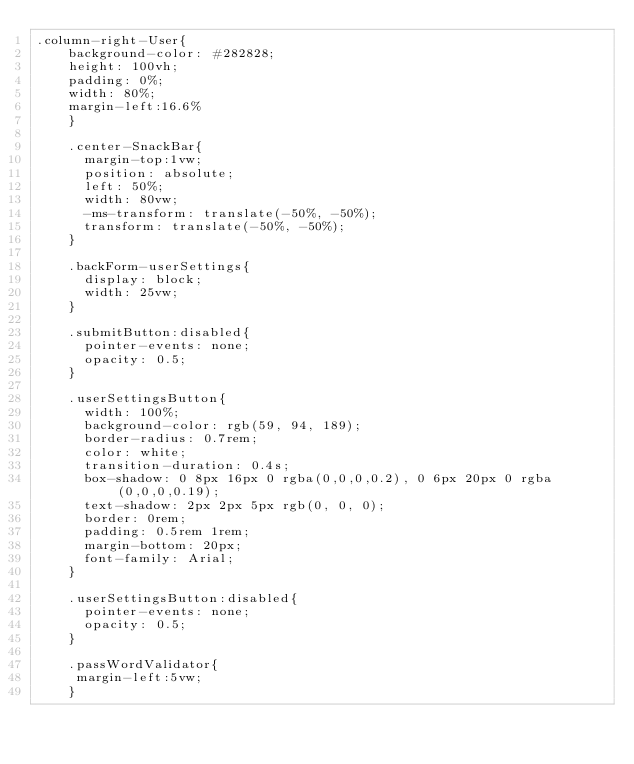<code> <loc_0><loc_0><loc_500><loc_500><_CSS_>.column-right-User{
    background-color: #282828;
    height: 100vh;
    padding: 0%;
    width: 80%;
    margin-left:16.6%
    }

    .center-SnackBar{
      margin-top:1vw;
      position: absolute;
      left: 50%;
      width: 80vw;
      -ms-transform: translate(-50%, -50%);
      transform: translate(-50%, -50%);
    }

    .backForm-userSettings{
      display: block;
      width: 25vw;
    }

    .submitButton:disabled{
      pointer-events: none;
      opacity: 0.5;
    }

    .userSettingsButton{
      width: 100%;
      background-color: rgb(59, 94, 189);
      border-radius: 0.7rem;
      color: white;
      transition-duration: 0.4s;
      box-shadow: 0 8px 16px 0 rgba(0,0,0,0.2), 0 6px 20px 0 rgba(0,0,0,0.19);
      text-shadow: 2px 2px 5px rgb(0, 0, 0);
      border: 0rem;
      padding: 0.5rem 1rem;
      margin-bottom: 20px;
      font-family: Arial;
    }

    .userSettingsButton:disabled{
      pointer-events: none;
      opacity: 0.5;
    }

    .passWordValidator{
     margin-left:5vw;
    }
</code> 